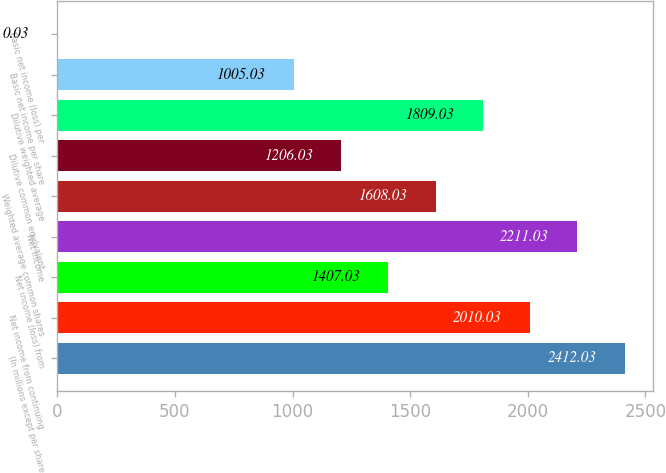<chart> <loc_0><loc_0><loc_500><loc_500><bar_chart><fcel>(In millions except per share<fcel>Net income from continuing<fcel>Net income (loss) from<fcel>Net income<fcel>Weighted average common shares<fcel>Dilutive common equivalent<fcel>Dilutive weighted average<fcel>Basic net income per share<fcel>Basic net income (loss) per<nl><fcel>2412.03<fcel>2010.03<fcel>1407.03<fcel>2211.03<fcel>1608.03<fcel>1206.03<fcel>1809.03<fcel>1005.03<fcel>0.03<nl></chart> 